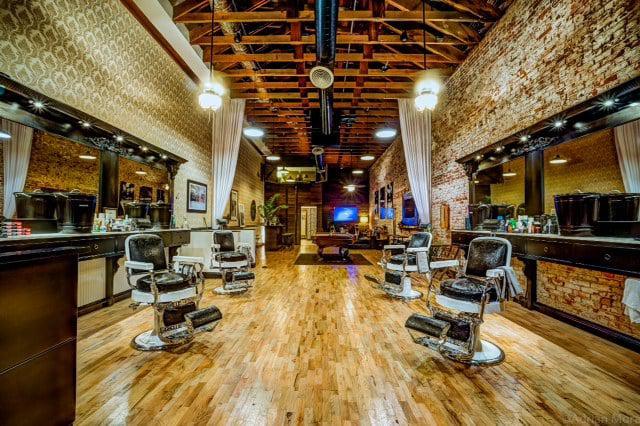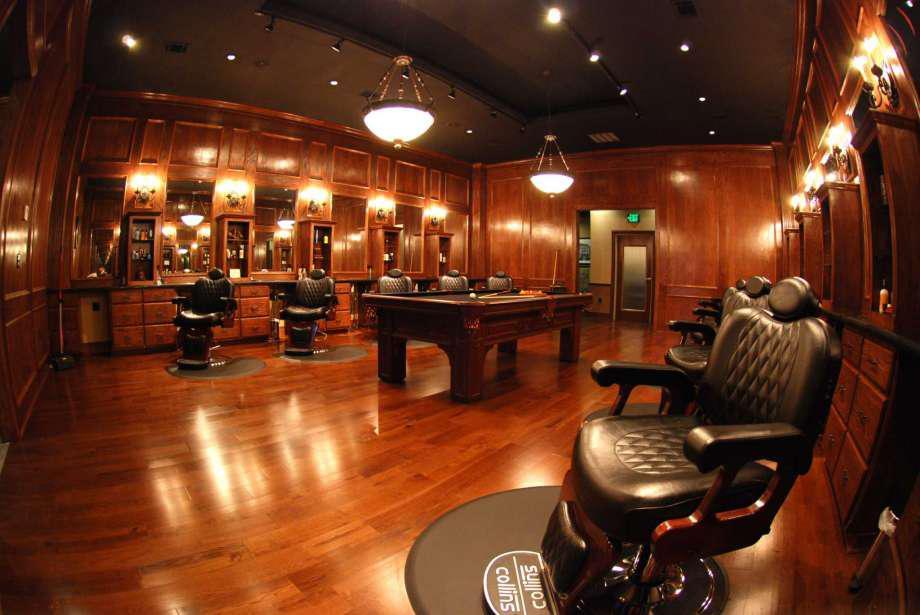The first image is the image on the left, the second image is the image on the right. Given the left and right images, does the statement "One of the images contains a bench for seating in the middle of the room" hold true? Answer yes or no. No. The first image is the image on the left, the second image is the image on the right. Analyze the images presented: Is the assertion "A long oblong counter with a peaked top is in the center of the salon, flanked by barber chairs, in one image." valid? Answer yes or no. No. 